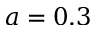<formula> <loc_0><loc_0><loc_500><loc_500>a = 0 . 3</formula> 